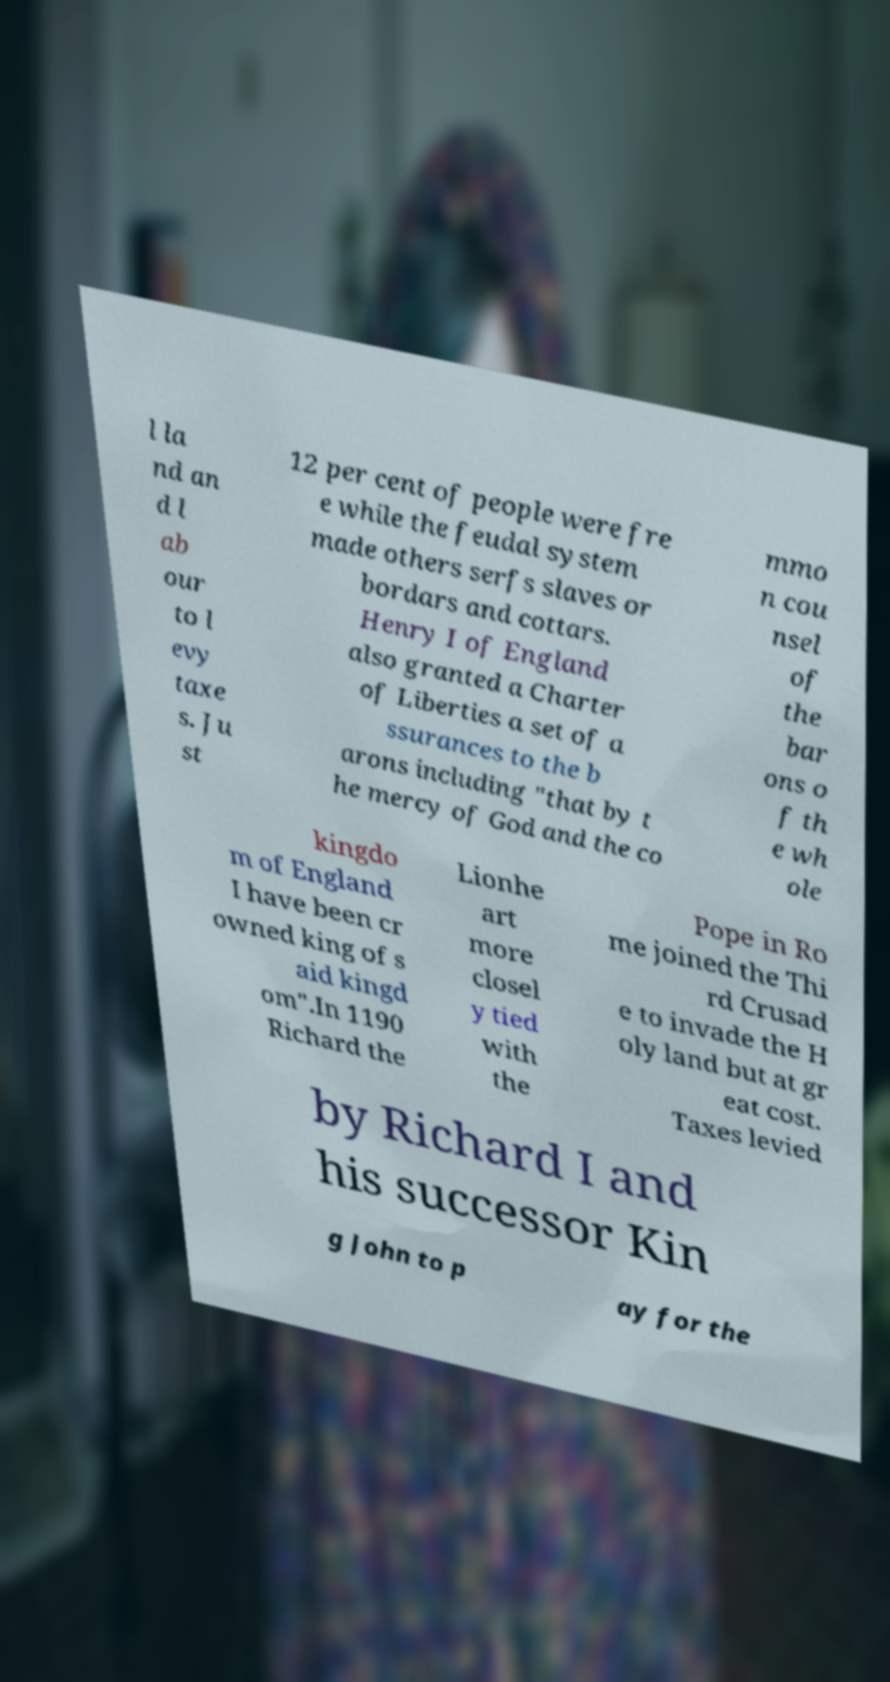There's text embedded in this image that I need extracted. Can you transcribe it verbatim? l la nd an d l ab our to l evy taxe s. Ju st 12 per cent of people were fre e while the feudal system made others serfs slaves or bordars and cottars. Henry I of England also granted a Charter of Liberties a set of a ssurances to the b arons including "that by t he mercy of God and the co mmo n cou nsel of the bar ons o f th e wh ole kingdo m of England I have been cr owned king of s aid kingd om".In 1190 Richard the Lionhe art more closel y tied with the Pope in Ro me joined the Thi rd Crusad e to invade the H oly land but at gr eat cost. Taxes levied by Richard I and his successor Kin g John to p ay for the 